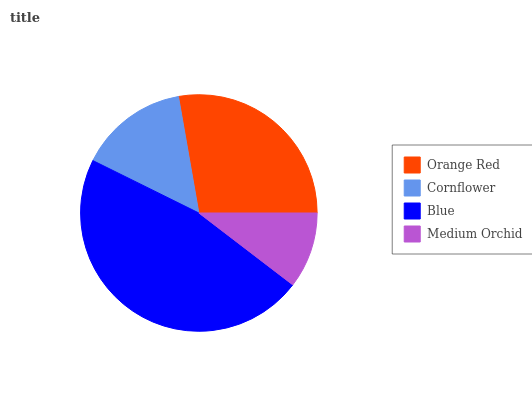Is Medium Orchid the minimum?
Answer yes or no. Yes. Is Blue the maximum?
Answer yes or no. Yes. Is Cornflower the minimum?
Answer yes or no. No. Is Cornflower the maximum?
Answer yes or no. No. Is Orange Red greater than Cornflower?
Answer yes or no. Yes. Is Cornflower less than Orange Red?
Answer yes or no. Yes. Is Cornflower greater than Orange Red?
Answer yes or no. No. Is Orange Red less than Cornflower?
Answer yes or no. No. Is Orange Red the high median?
Answer yes or no. Yes. Is Cornflower the low median?
Answer yes or no. Yes. Is Medium Orchid the high median?
Answer yes or no. No. Is Medium Orchid the low median?
Answer yes or no. No. 